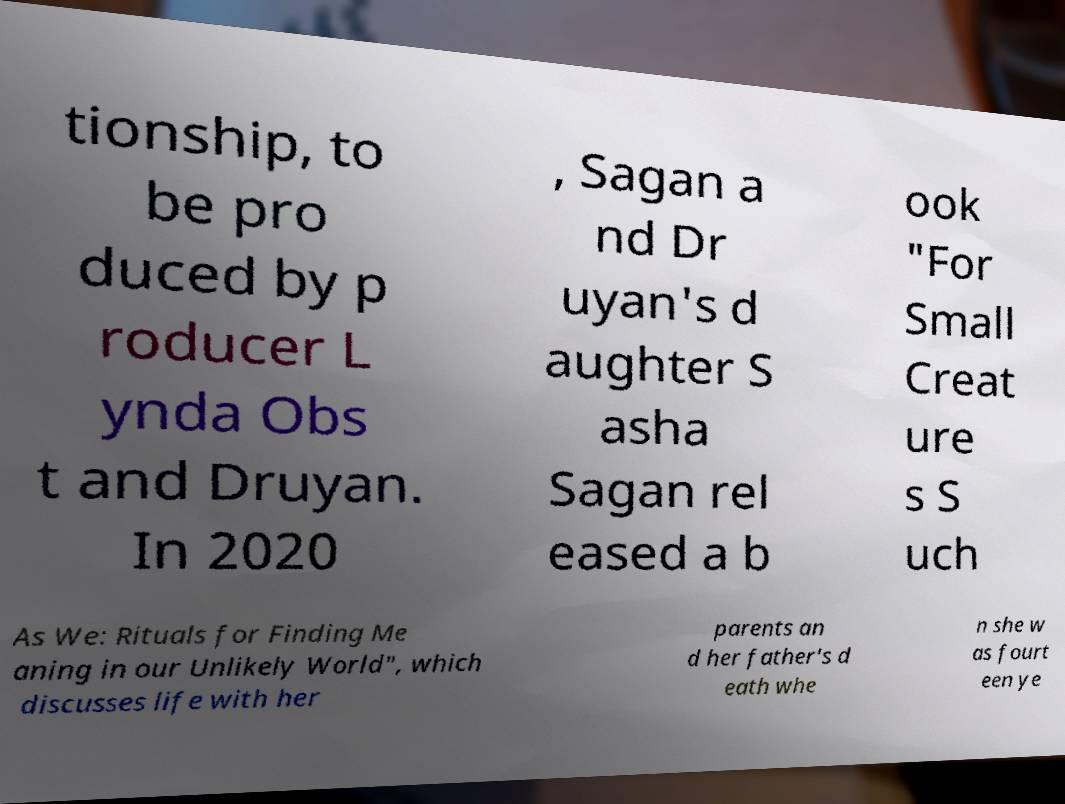There's text embedded in this image that I need extracted. Can you transcribe it verbatim? tionship, to be pro duced by p roducer L ynda Obs t and Druyan. In 2020 , Sagan a nd Dr uyan's d aughter S asha Sagan rel eased a b ook "For Small Creat ure s S uch As We: Rituals for Finding Me aning in our Unlikely World", which discusses life with her parents an d her father's d eath whe n she w as fourt een ye 